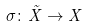<formula> <loc_0><loc_0><loc_500><loc_500>\sigma \colon \tilde { X } \rightarrow X</formula> 